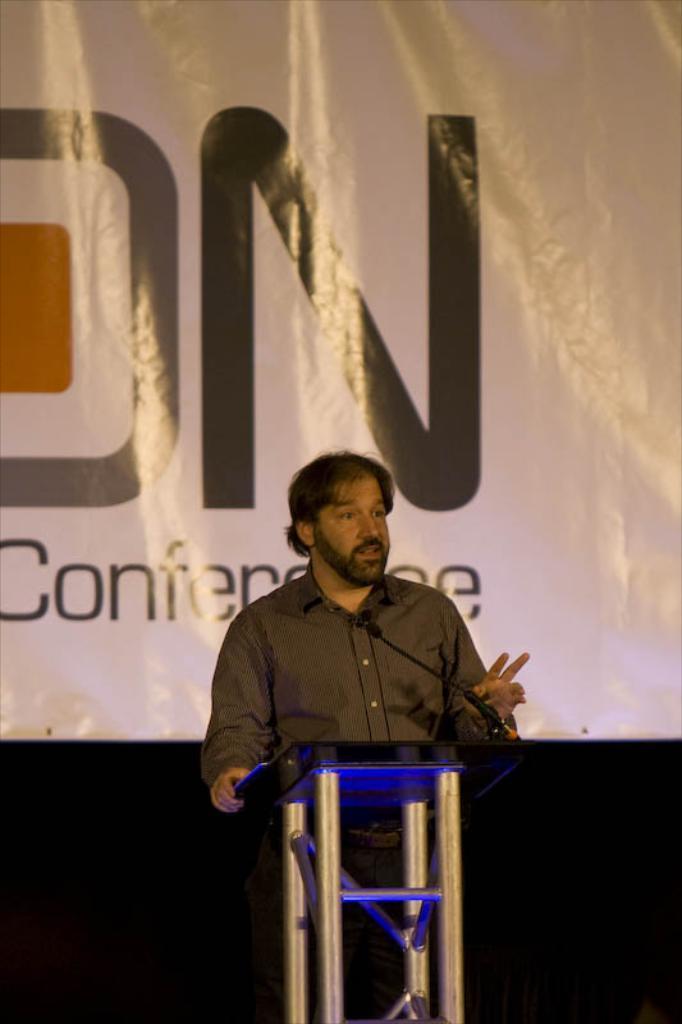In one or two sentences, can you explain what this image depicts? In this image in the middle there is a man, he wears a shirt, he is speaking, in front of him there is a podium and mic. In the background there is a poster, text. 